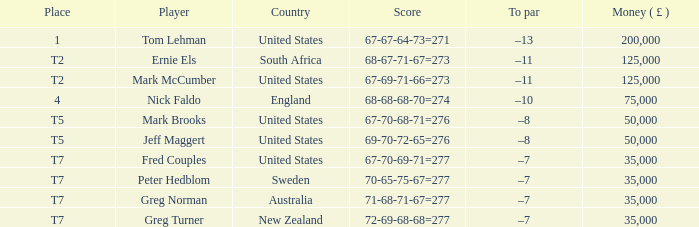What is To par, when Player is "Greg Turner"? –7. 